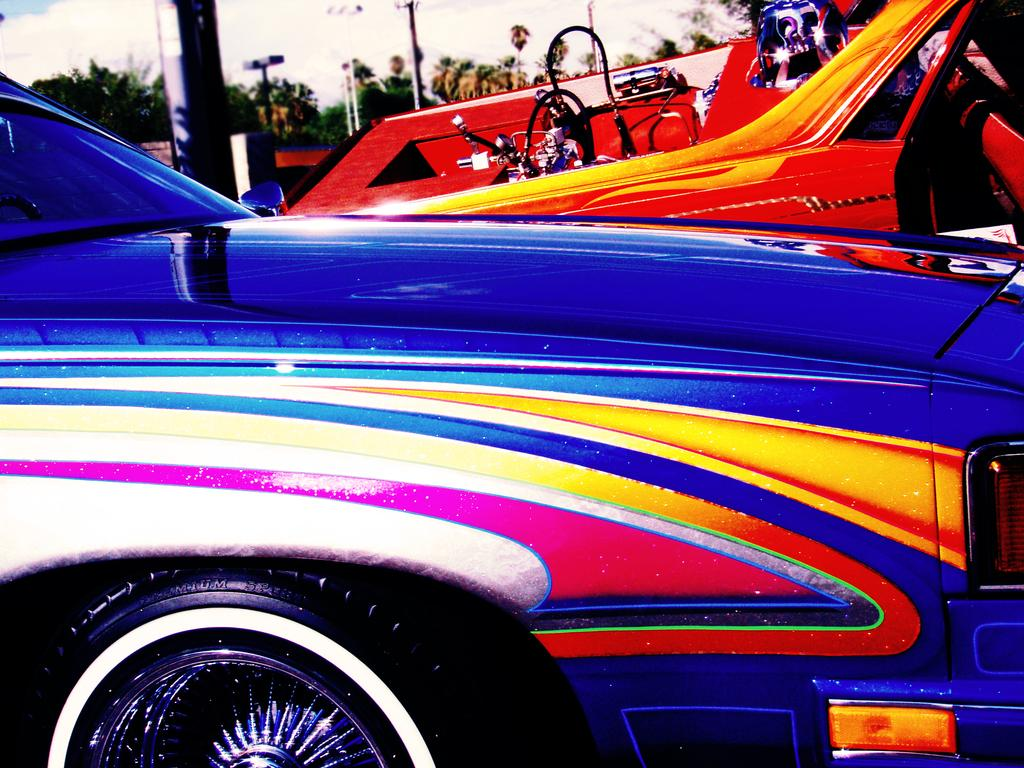What types of vehicles are in the image? There are two colorful cars and a bike in the image. Who is riding the bike in the image? A person is riding the bike in the image. What safety precaution is the person on the bike taking? The person on the bike is wearing a helmet. What type of natural elements can be seen in the image? There are trees in the image. What architectural elements can be seen in the image? There are poles in the image. What is visible at the top of the image? The sky is visible at the top of the image. What type of smoke is coming out of the truck in the image? There is no truck present in the image, so there is no smoke to be observed. 